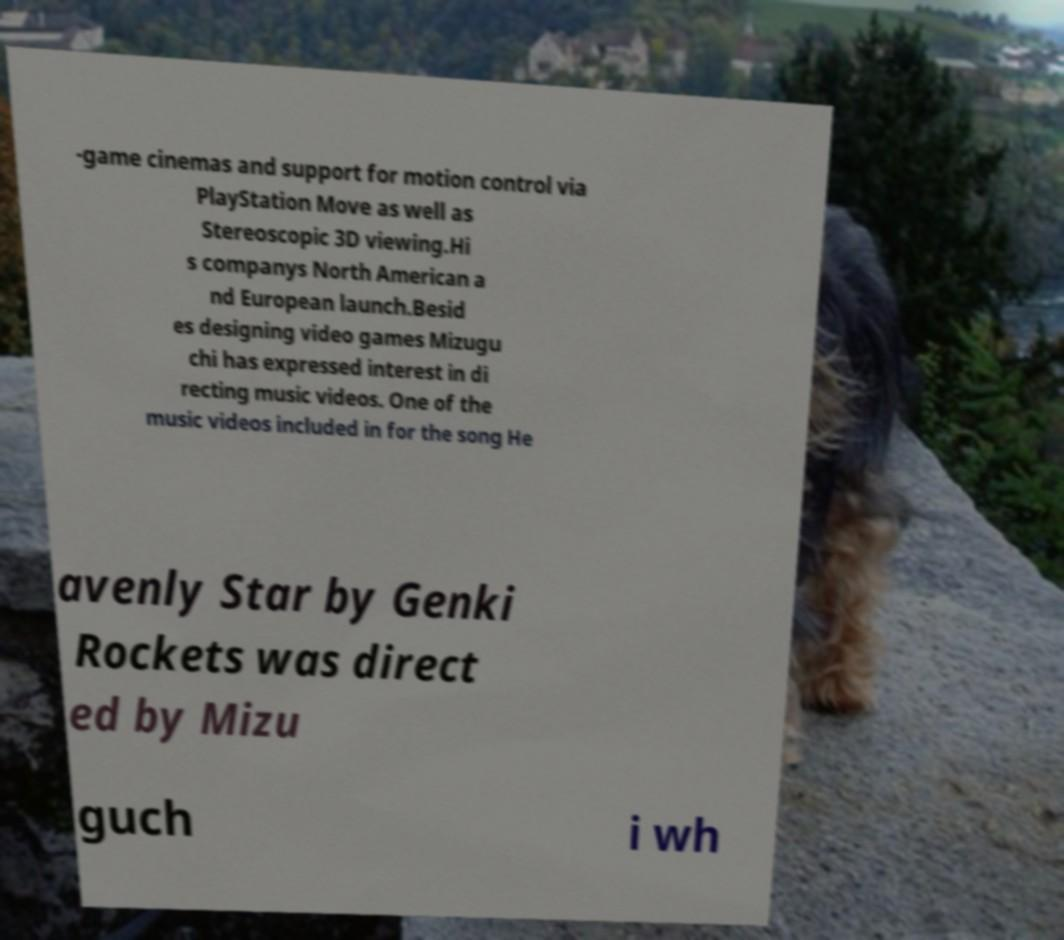Please identify and transcribe the text found in this image. -game cinemas and support for motion control via PlayStation Move as well as Stereoscopic 3D viewing.Hi s companys North American a nd European launch.Besid es designing video games Mizugu chi has expressed interest in di recting music videos. One of the music videos included in for the song He avenly Star by Genki Rockets was direct ed by Mizu guch i wh 